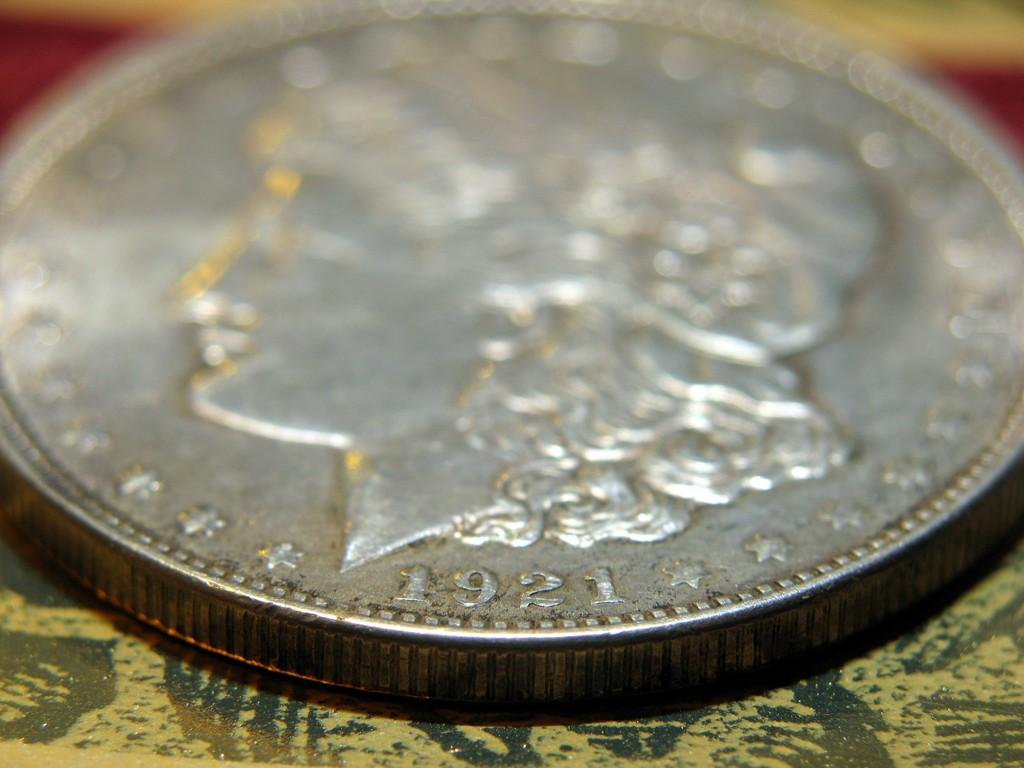<image>
Create a compact narrative representing the image presented. Despite being made in 1921, this silver coin is in good shape. 